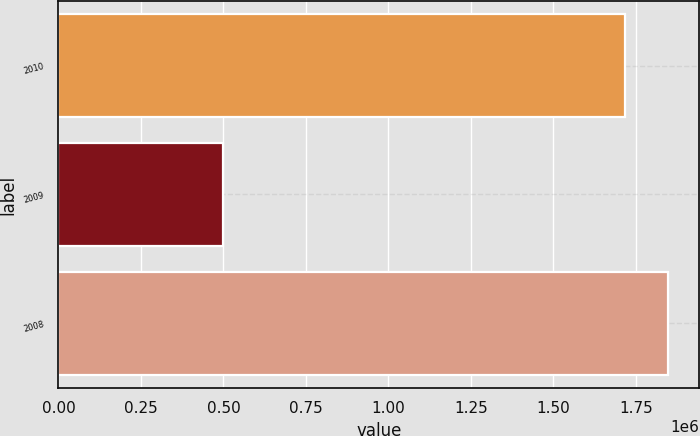<chart> <loc_0><loc_0><loc_500><loc_500><bar_chart><fcel>2010<fcel>2009<fcel>2008<nl><fcel>1.71668e+06<fcel>500097<fcel>1.84855e+06<nl></chart> 